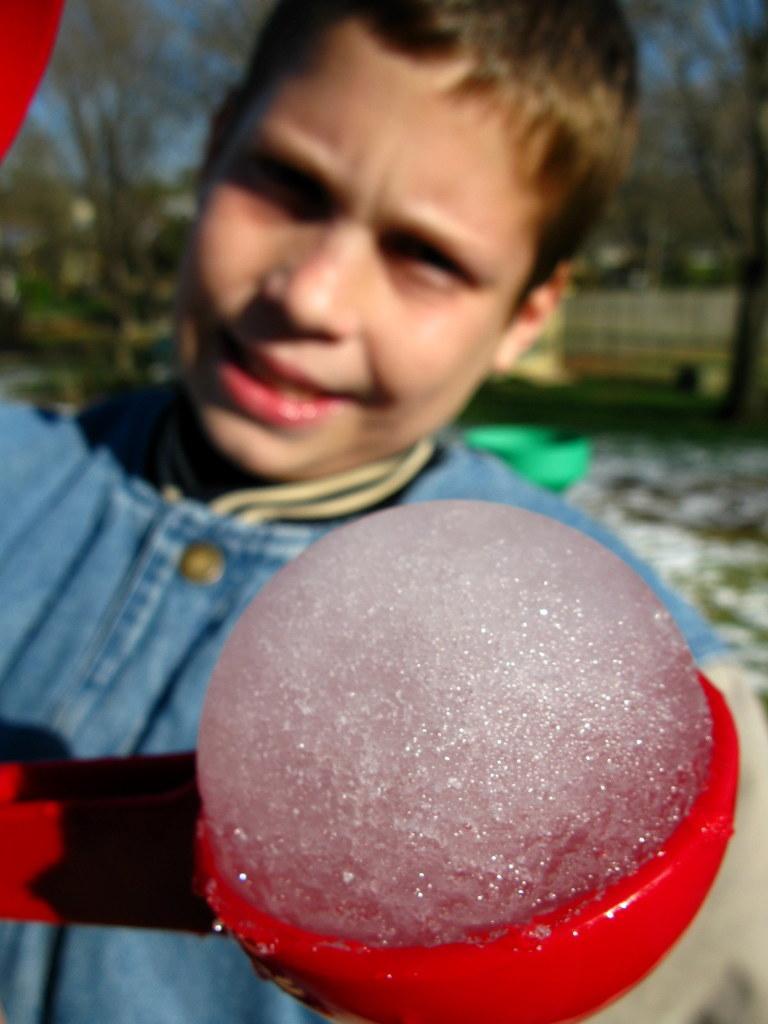Please provide a concise description of this image. In the center of the image there is a person holding a object. In the background we can see trees and buildings. 